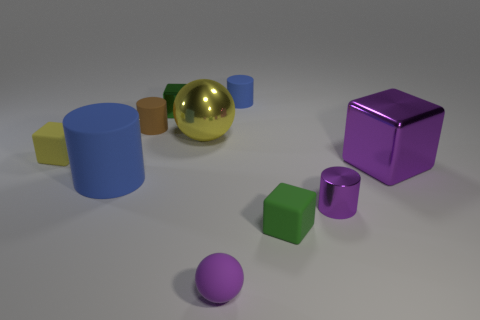There is a small shiny object that is in front of the large sphere; what shape is it?
Give a very brief answer. Cylinder. How many purple things are matte balls or small rubber blocks?
Keep it short and to the point. 1. Are the tiny purple ball and the tiny yellow thing made of the same material?
Offer a terse response. Yes. There is a big metal cube; what number of objects are left of it?
Provide a succinct answer. 9. What is the tiny thing that is on the right side of the large yellow ball and behind the yellow sphere made of?
Offer a very short reply. Rubber. How many balls are big red metallic objects or small green metal things?
Keep it short and to the point. 0. There is a tiny blue object that is the same shape as the brown object; what material is it?
Keep it short and to the point. Rubber. The purple block that is made of the same material as the large yellow thing is what size?
Offer a very short reply. Large. There is a green metallic thing that is to the right of the tiny brown matte object; does it have the same shape as the big purple object that is right of the tiny blue cylinder?
Keep it short and to the point. Yes. What is the color of the tiny cylinder that is made of the same material as the brown thing?
Your response must be concise. Blue. 